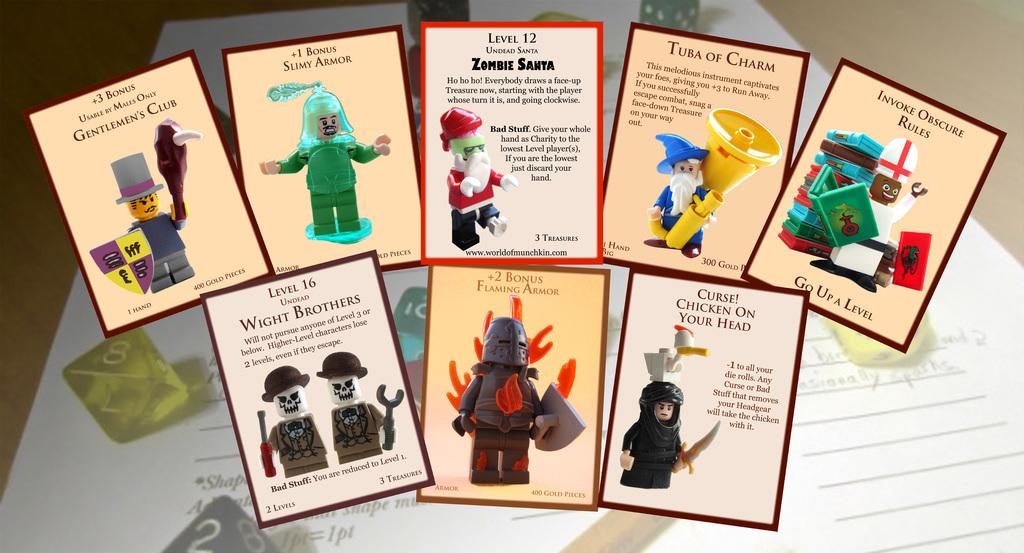<image>
Present a compact description of the photo's key features. A bunch of lego playing cards including 'slimy armor' 